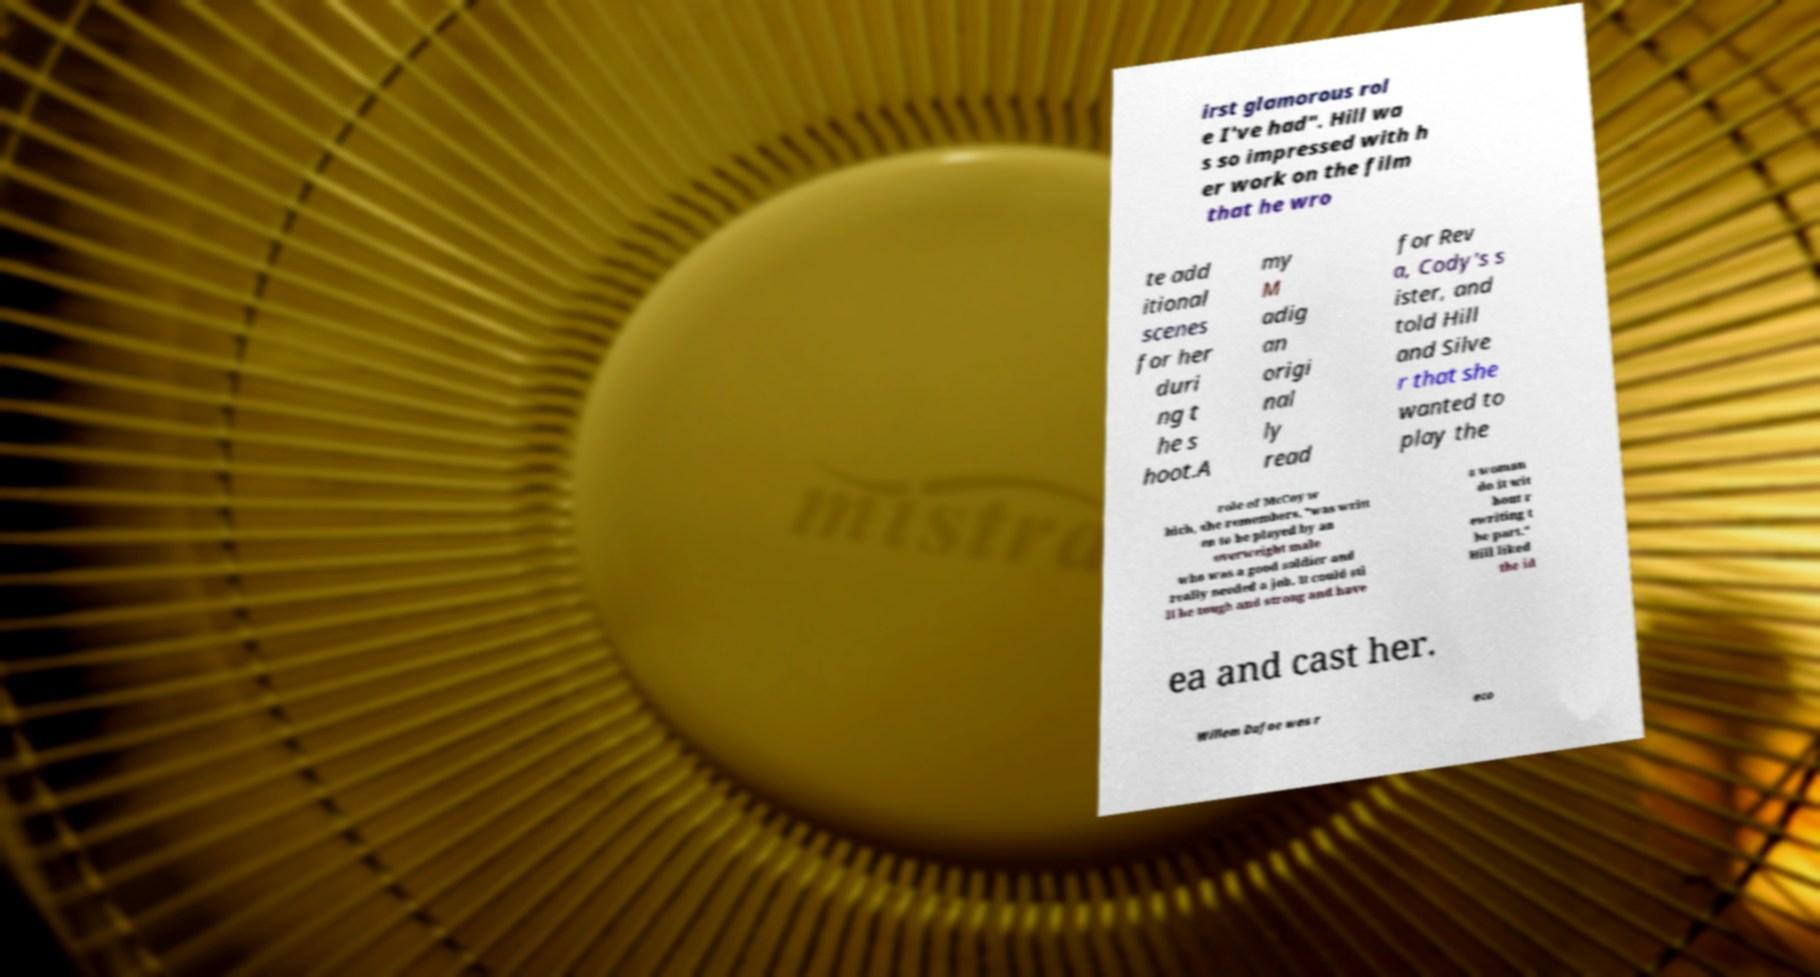What messages or text are displayed in this image? I need them in a readable, typed format. irst glamorous rol e I've had". Hill wa s so impressed with h er work on the film that he wro te add itional scenes for her duri ng t he s hoot.A my M adig an origi nal ly read for Rev a, Cody's s ister, and told Hill and Silve r that she wanted to play the role of McCoy w hich, she remembers, "was writt en to be played by an overweight male who was a good soldier and really needed a job. It could sti ll be tough and strong and have a woman do it wit hout r ewriting t he part." Hill liked the id ea and cast her. Willem Dafoe was r eco 